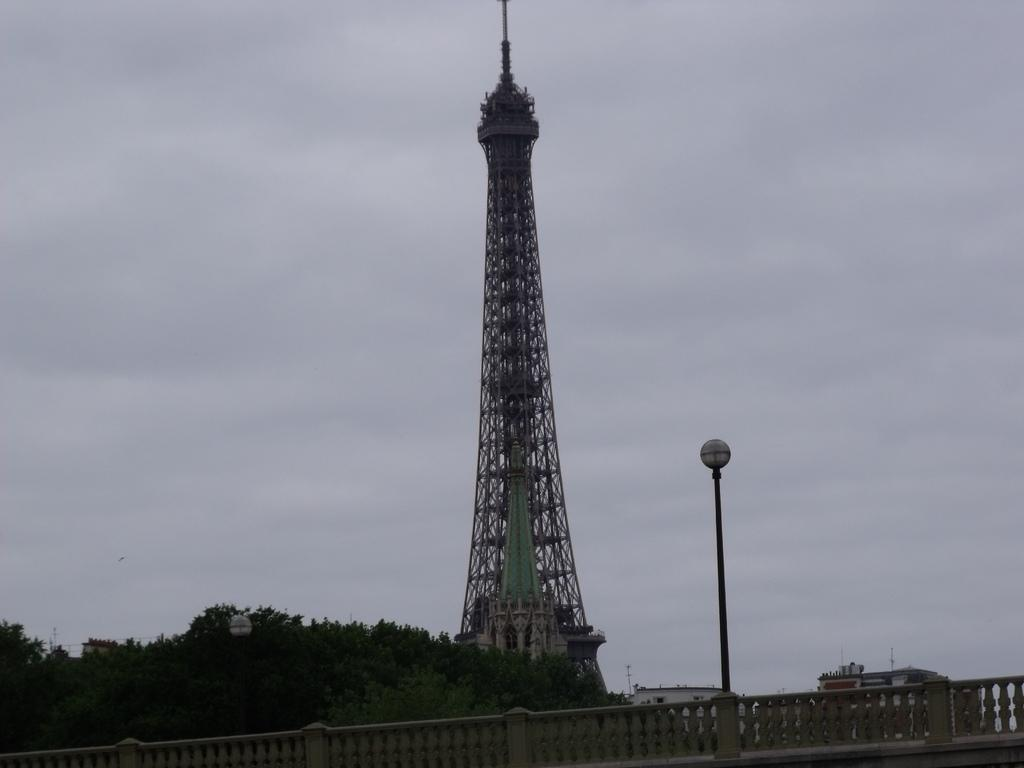What is the main structure in the center of the image? There is a tower in the center of the image. What can be seen in the background of the image? There are buildings, trees, a pole, and a bridge in the background of the image. Can you suggest a way to improve the elbow's design in the image? There is no elbow present in the image, as it features a tower, buildings, trees, a pole, and a bridge. 